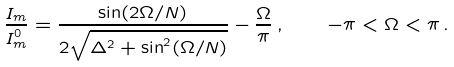Convert formula to latex. <formula><loc_0><loc_0><loc_500><loc_500>\frac { I _ { m } } { I _ { m } ^ { 0 } } = \frac { \sin ( 2 \Omega / N ) } { 2 \sqrt { \Delta ^ { 2 } + \sin ^ { 2 } ( \Omega / N ) } } - \frac { \Omega } { \pi } \, , \quad - \pi < \Omega < \pi \, .</formula> 